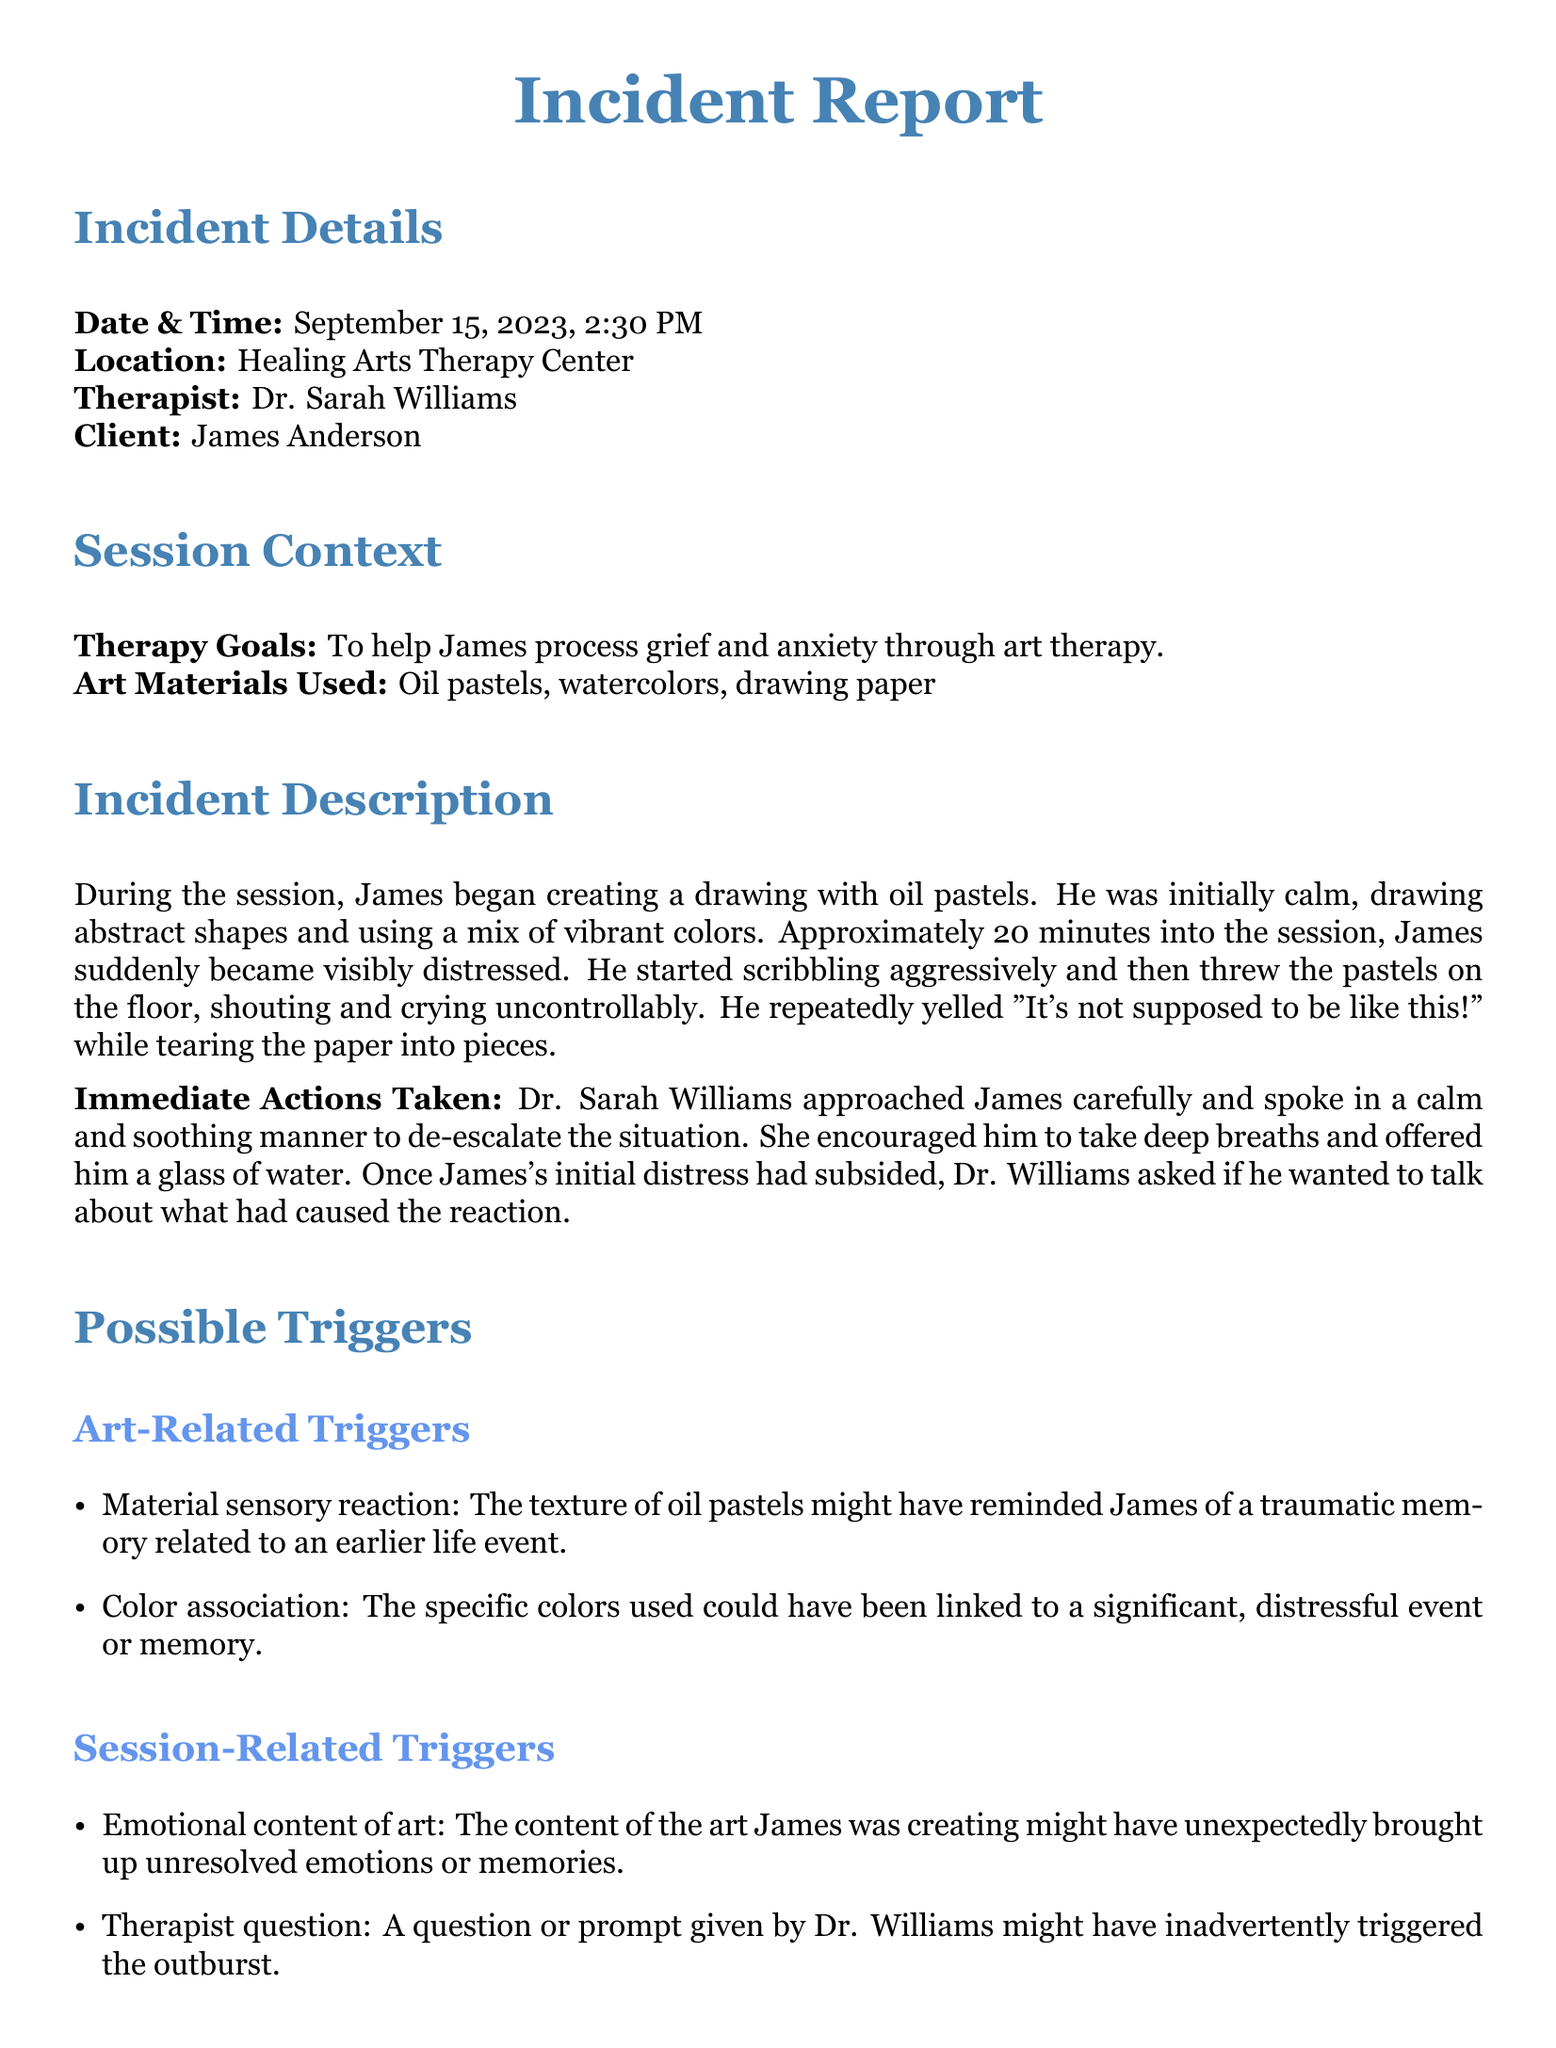what is the date of the incident? The date of the incident is specified in the report as September 15, 2023.
Answer: September 15, 2023 who is the therapist mentioned in the report? The incident report lists Dr. Sarah Williams as the therapist.
Answer: Dr. Sarah Williams what art materials were used during the session? The document states that oil pastels and watercolors were among the art materials used.
Answer: Oil pastels, watercolors what was James doing before the outburst? Before the outburst, James was creating a drawing with oil pastels.
Answer: Creating a drawing what emotional state did James exhibit approximately 20 minutes into the session? The report indicates that James became visibly distressed about 20 minutes into the session.
Answer: Visibly distressed what might have triggered James's emotional outburst? The report lists potential triggers, including emotional content of art and personal loss.
Answer: Emotional content of art, personal loss what immediate action was taken by Dr. Williams? According to the document, Dr. Williams approached James carefully and spoke in a calm and soothing manner.
Answer: Spoke in a calm and soothing manner how long after starting the session did the outburst occur? The outburst occurred approximately 20 minutes into the session.
Answer: 20 minutes what recommendation is made regarding the environment? One recommendation is to ensure a safe environment by removing potentially harmful materials.
Answer: Ensure a safe environment who is James's brother, as mentioned in the recommendations? The report refers to Alex Anderson as James's brother.
Answer: Alex Anderson 